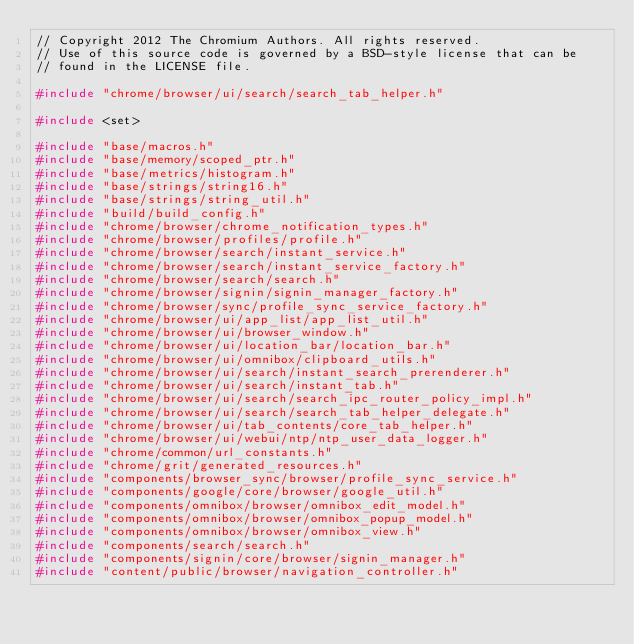<code> <loc_0><loc_0><loc_500><loc_500><_C++_>// Copyright 2012 The Chromium Authors. All rights reserved.
// Use of this source code is governed by a BSD-style license that can be
// found in the LICENSE file.

#include "chrome/browser/ui/search/search_tab_helper.h"

#include <set>

#include "base/macros.h"
#include "base/memory/scoped_ptr.h"
#include "base/metrics/histogram.h"
#include "base/strings/string16.h"
#include "base/strings/string_util.h"
#include "build/build_config.h"
#include "chrome/browser/chrome_notification_types.h"
#include "chrome/browser/profiles/profile.h"
#include "chrome/browser/search/instant_service.h"
#include "chrome/browser/search/instant_service_factory.h"
#include "chrome/browser/search/search.h"
#include "chrome/browser/signin/signin_manager_factory.h"
#include "chrome/browser/sync/profile_sync_service_factory.h"
#include "chrome/browser/ui/app_list/app_list_util.h"
#include "chrome/browser/ui/browser_window.h"
#include "chrome/browser/ui/location_bar/location_bar.h"
#include "chrome/browser/ui/omnibox/clipboard_utils.h"
#include "chrome/browser/ui/search/instant_search_prerenderer.h"
#include "chrome/browser/ui/search/instant_tab.h"
#include "chrome/browser/ui/search/search_ipc_router_policy_impl.h"
#include "chrome/browser/ui/search/search_tab_helper_delegate.h"
#include "chrome/browser/ui/tab_contents/core_tab_helper.h"
#include "chrome/browser/ui/webui/ntp/ntp_user_data_logger.h"
#include "chrome/common/url_constants.h"
#include "chrome/grit/generated_resources.h"
#include "components/browser_sync/browser/profile_sync_service.h"
#include "components/google/core/browser/google_util.h"
#include "components/omnibox/browser/omnibox_edit_model.h"
#include "components/omnibox/browser/omnibox_popup_model.h"
#include "components/omnibox/browser/omnibox_view.h"
#include "components/search/search.h"
#include "components/signin/core/browser/signin_manager.h"
#include "content/public/browser/navigation_controller.h"</code> 